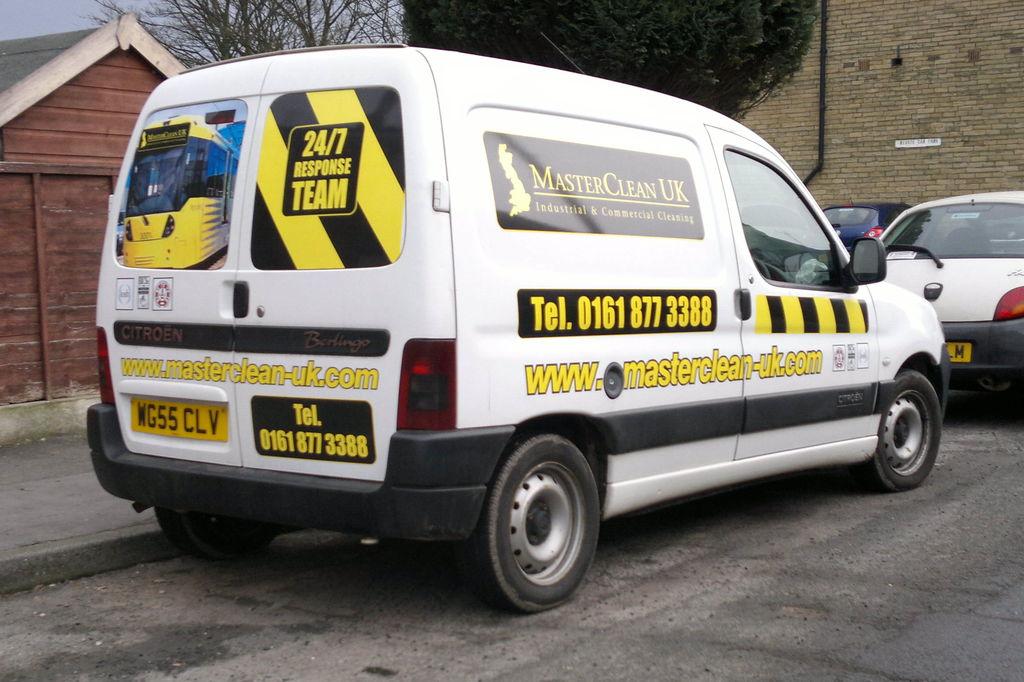During what hours of the day can the team respond?
Your answer should be very brief. 24/7. What is the company's phone number?
Ensure brevity in your answer.  01618773388. 